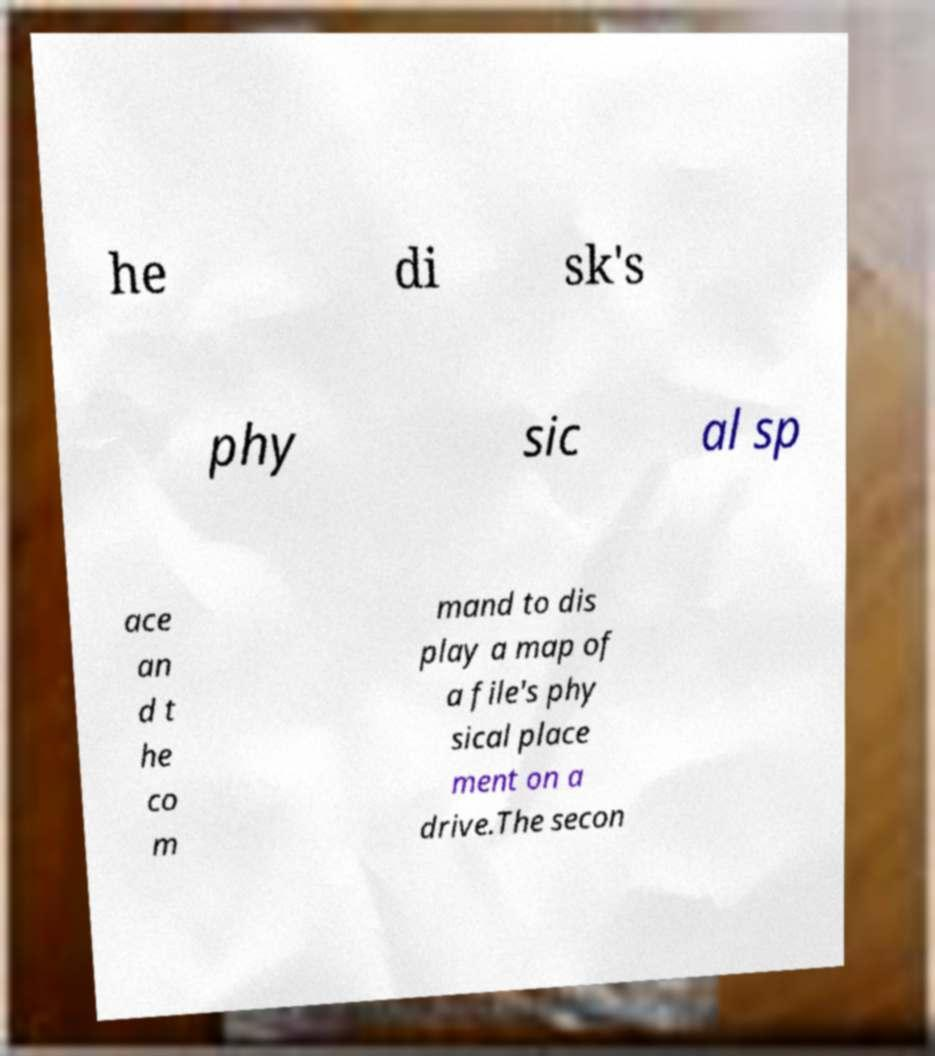Please identify and transcribe the text found in this image. he di sk's phy sic al sp ace an d t he co m mand to dis play a map of a file's phy sical place ment on a drive.The secon 